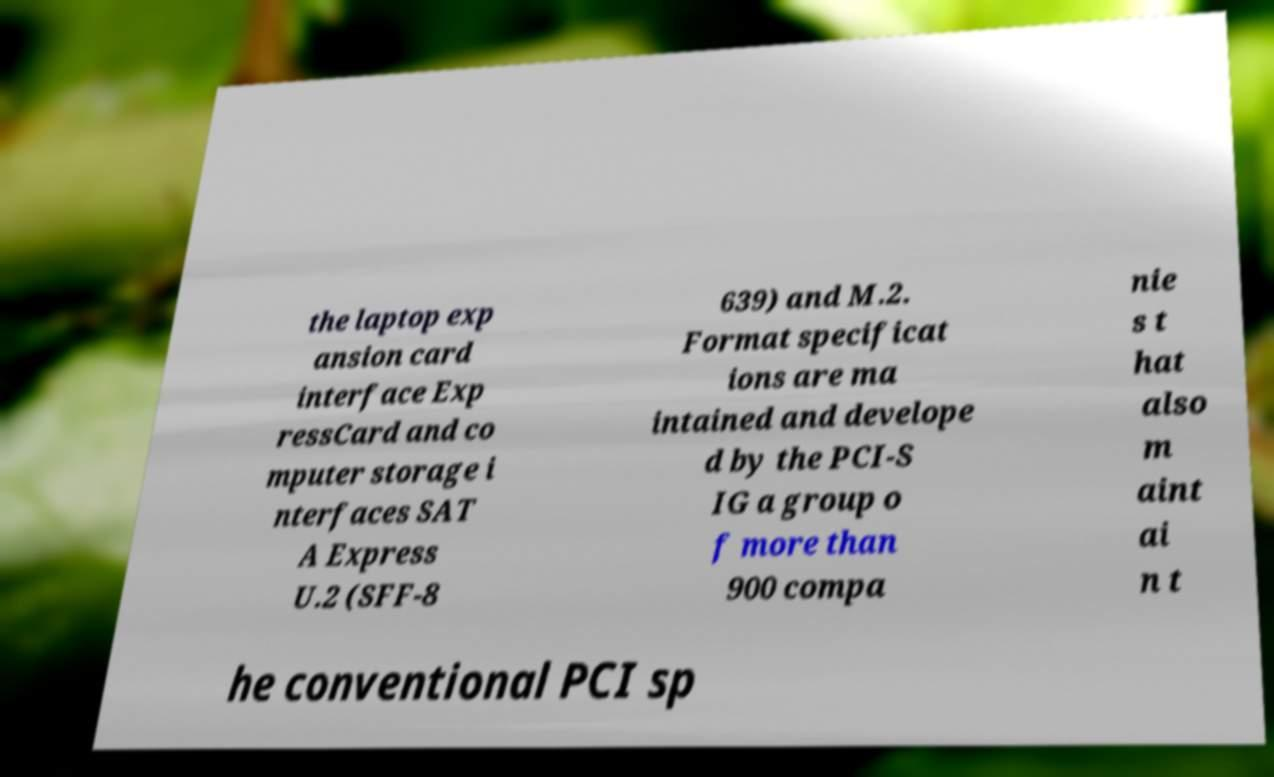I need the written content from this picture converted into text. Can you do that? the laptop exp ansion card interface Exp ressCard and co mputer storage i nterfaces SAT A Express U.2 (SFF-8 639) and M.2. Format specificat ions are ma intained and develope d by the PCI-S IG a group o f more than 900 compa nie s t hat also m aint ai n t he conventional PCI sp 